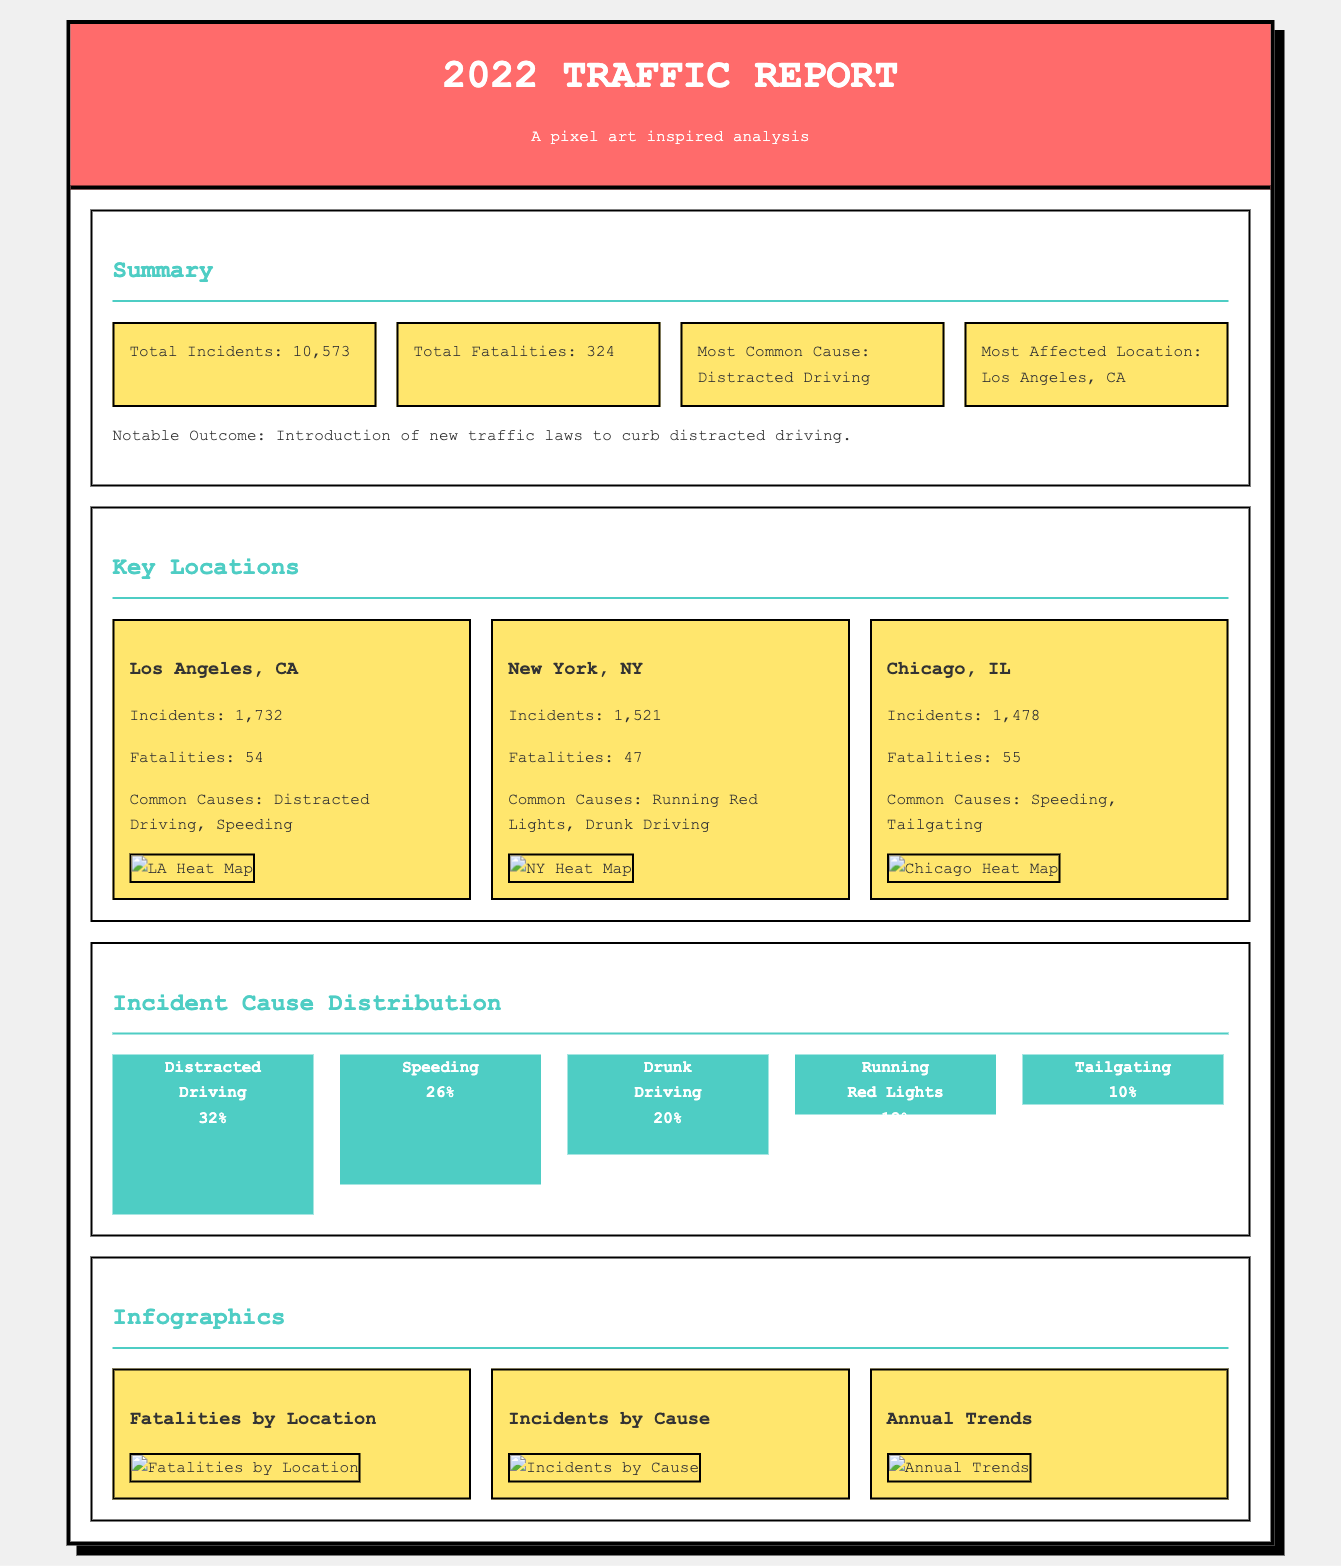what is the total number of incidents in 2022? The total number of incidents is provided in the summary section, which states 10,573 incidents occurred.
Answer: 10,573 what was the most common cause of accidents? The document explicitly states that the most common cause of accidents was distracted driving.
Answer: Distracted Driving which city had the highest number of incidents? According to the key locations section, Los Angeles, CA reported the highest number of incidents at 1,732.
Answer: Los Angeles, CA how many fatalities occurred in New York, NY? The number of fatalities is mentioned for New York, NY in the key locations section, which indicates there were 47 fatalities.
Answer: 47 what percentage of incidents were caused by speeding? The document presents cause distribution data and specifies that speeding accounted for 26% of the incidents.
Answer: 26% which location had the most fatalities? The key locations section lists the fatalities, with Los Angeles, CA having 54 fatalities, which is the highest among the listed locations.
Answer: Los Angeles, CA how many incidents were reported in Chicago, IL? The key locations section provides the figure for incidents in Chicago, IL as 1,478.
Answer: 1,478 what are the common causes of incidents in Chicago, IL? The key locations section states that the common causes in Chicago, IL were speeding and tailgating.
Answer: Speeding, Tailgating what notable outcome was mentioned in the summary? In the summary section, it mentions the introduction of new traffic laws to curb distracted driving as a notable outcome.
Answer: Introduction of new traffic laws to curb distracted driving 